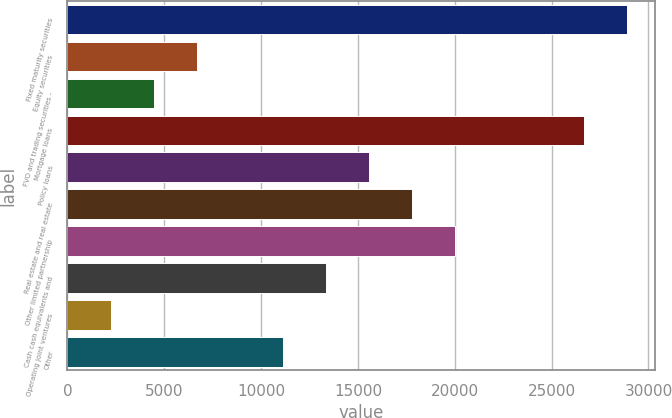<chart> <loc_0><loc_0><loc_500><loc_500><bar_chart><fcel>Fixed maturity securities<fcel>Equity securities<fcel>FVO and trading securities -<fcel>Mortgage loans<fcel>Policy loans<fcel>Real estate and real estate<fcel>Other limited partnership<fcel>Cash cash equivalents and<fcel>Operating joint ventures<fcel>Other<nl><fcel>28900.7<fcel>6671.7<fcel>4448.8<fcel>26677.8<fcel>15563.3<fcel>17786.2<fcel>20009.1<fcel>13340.4<fcel>2225.9<fcel>11117.5<nl></chart> 